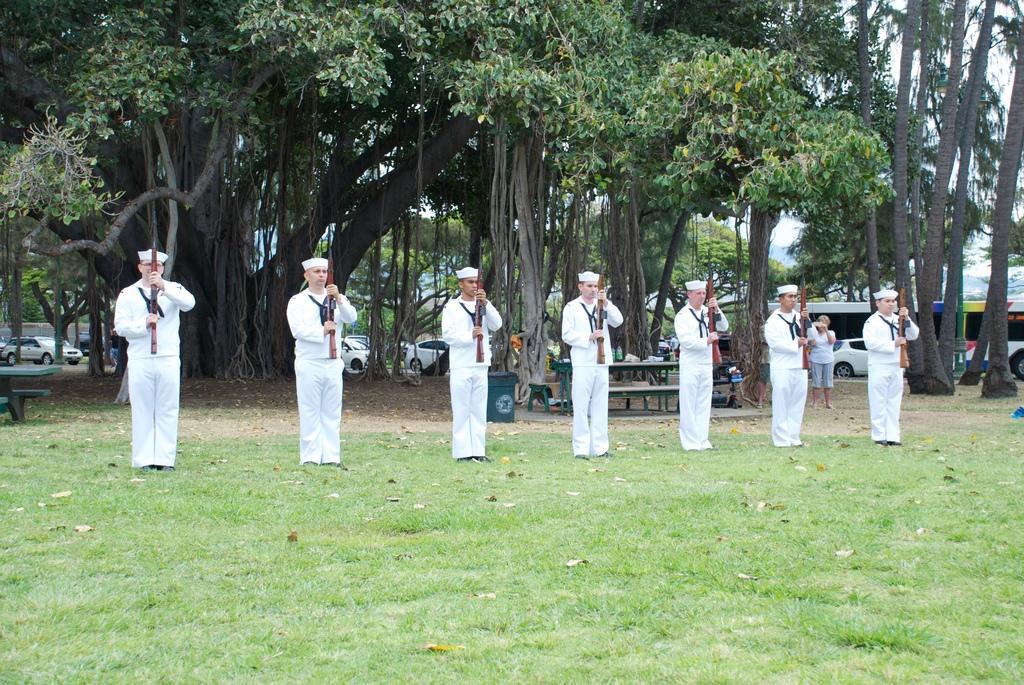Could you give a brief overview of what you see in this image? In this picture I can see few people standing on the grass and holding guns, side there are few people standing and taking pictures and also some benches, some objects, behind I can see some vehicles on the road, trees and buildings. 